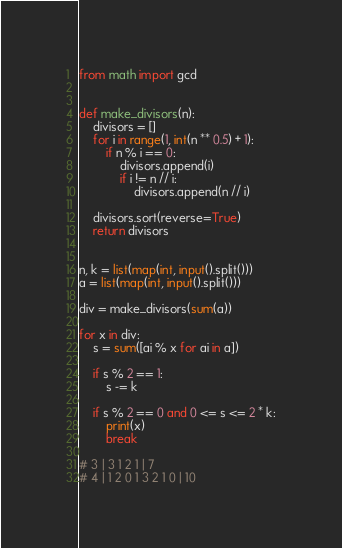<code> <loc_0><loc_0><loc_500><loc_500><_Python_>from math import gcd


def make_divisors(n):
    divisors = []
    for i in range(1, int(n ** 0.5) + 1):
        if n % i == 0:
            divisors.append(i)
            if i != n // i:
                divisors.append(n // i)

    divisors.sort(reverse=True)
    return divisors


n, k = list(map(int, input().split()))
a = list(map(int, input().split()))

div = make_divisors(sum(a))

for x in div:
    s = sum([ai % x for ai in a])

    if s % 2 == 1:
        s -= k

    if s % 2 == 0 and 0 <= s <= 2 * k:
        print(x)
        break

# 3 | 3 1 2 1 | 7
# 4 | 1 2 0 1 3 2 1 0 | 10
</code> 